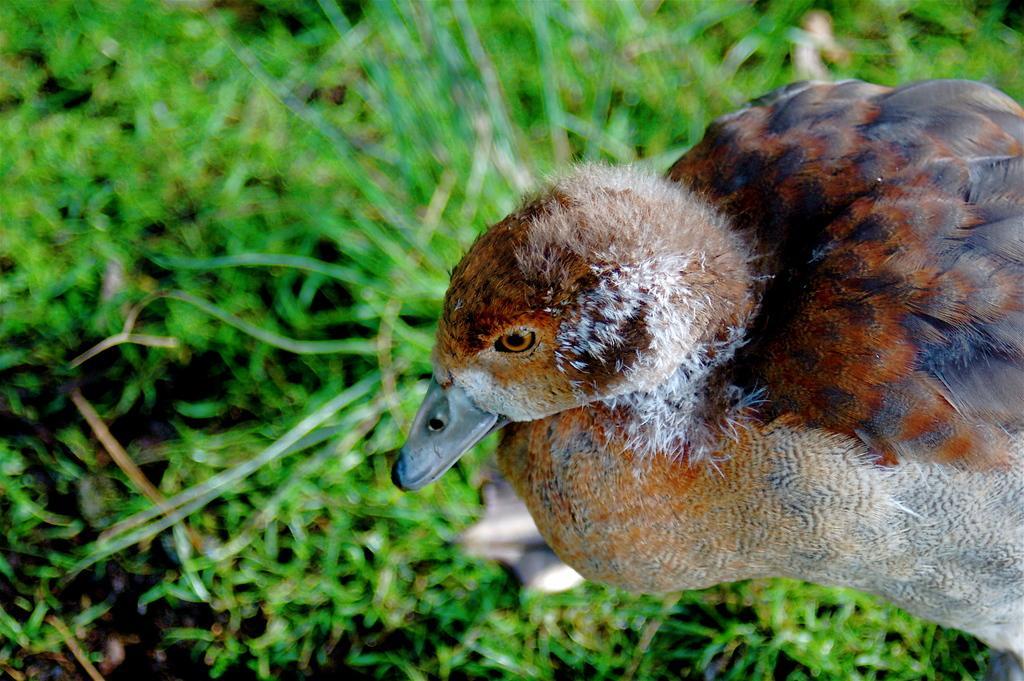Could you give a brief overview of what you see in this image? In this image we can see a duck standing on a grass field. 